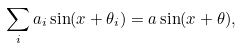Convert formula to latex. <formula><loc_0><loc_0><loc_500><loc_500>\sum _ { i } a _ { i } \sin ( x + \theta _ { i } ) = a \sin ( x + \theta ) ,</formula> 